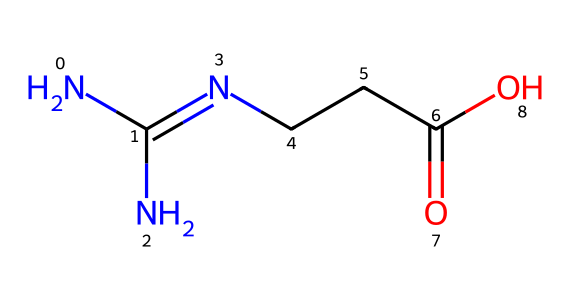What is the name of this chemical? The SMILES representation NC(N)=NCCC(=O)O corresponds to creatine, which is a well-known supplement used in sports and bodybuilding.
Answer: creatine How many nitrogen atoms are present in this structure? In the SMILES, we can identify three nitrogen atoms represented by 'N'. They appear at the beginning and within the chemical structure.
Answer: three What functional group is present in this chemical? The chemical structure has a carboxylic acid functional group, indicated by "C(=O)O" in the SMILES representation. This denotes the presence of a carbonyl and hydroxyl group.
Answer: carboxylic acid Which part of this chemical is responsible for its energy-boosting properties? The presence of the guanidine group (found in the structure NC(N)=N) in creatine plays a crucial role in its energy production, as it is involved in the formation of ATP.
Answer: guanidine group Is this chemical classified as a ketone? The structure does not feature the typical carbonyl group sandwiched between two carbon atoms that define a ketone. Instead, it contains a carboxylic acid group.
Answer: no What is the total number of carbon atoms in this molecule? By examining the SMILES representation, we can count the carbon atoms which appear as 'C'. There are four carbon atoms represented in the structure.
Answer: four Does this chemical contain any double bonds? The presence of the '=' sign in the SMILES indicates a double bond. Specifically, there's one double bond in the carbonyl group (C=O).
Answer: yes 